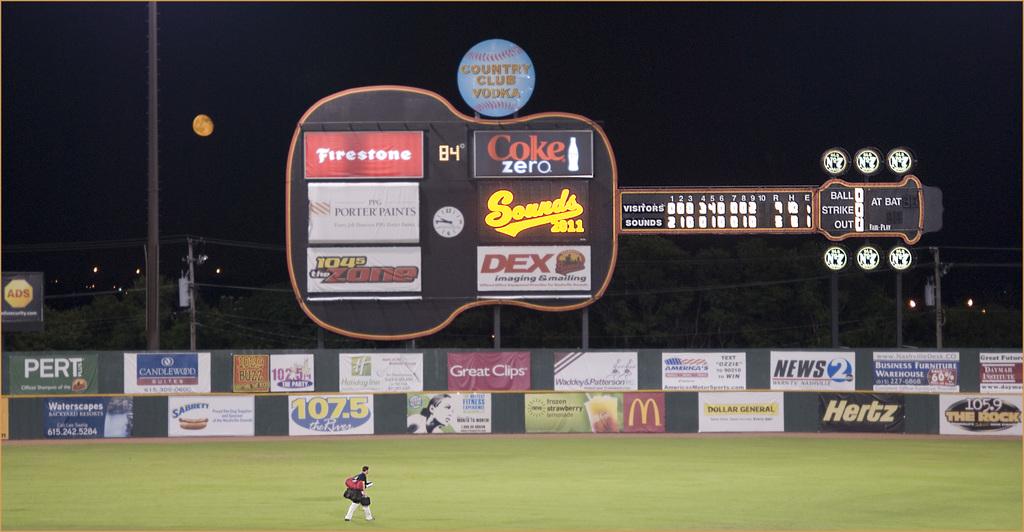Who is sponsoring this event?
Provide a succinct answer. Coke zero. What is the temperature according to the sign?
Ensure brevity in your answer.  84. 